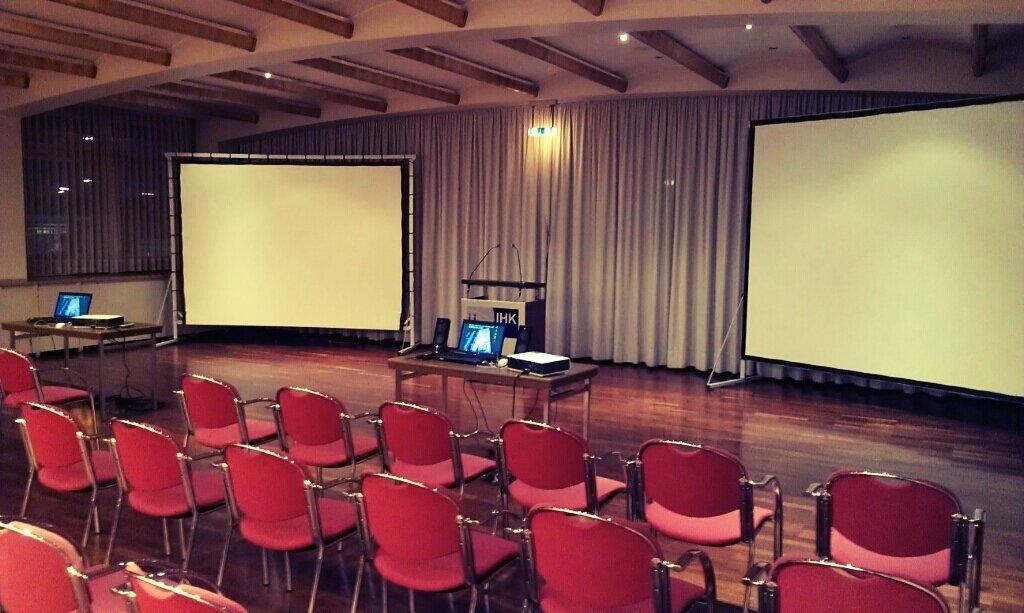How would you summarize this image in a sentence or two? There are red color chairs arranged on the floor. In the background, there are laptops and other objects arranged on the tables, there are two white color screens arranged, there is a stand on which there are two mics, there are lights attached to the roof and there are two curtains. 